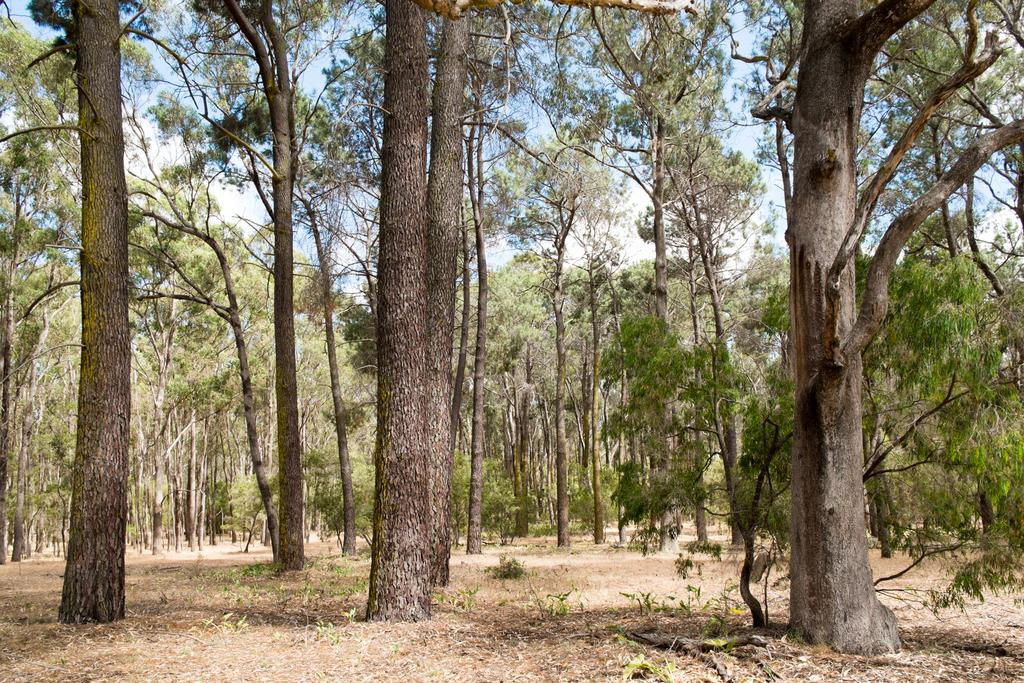What type of vegetation can be seen in the image? There are trees and plants in the image. What part of the natural environment is visible in the image? The sky is visible in the image. What type of cactus can be seen in the downtown area in the image? There is no cactus or downtown area present in the image; it features trees, plants, and the sky. 